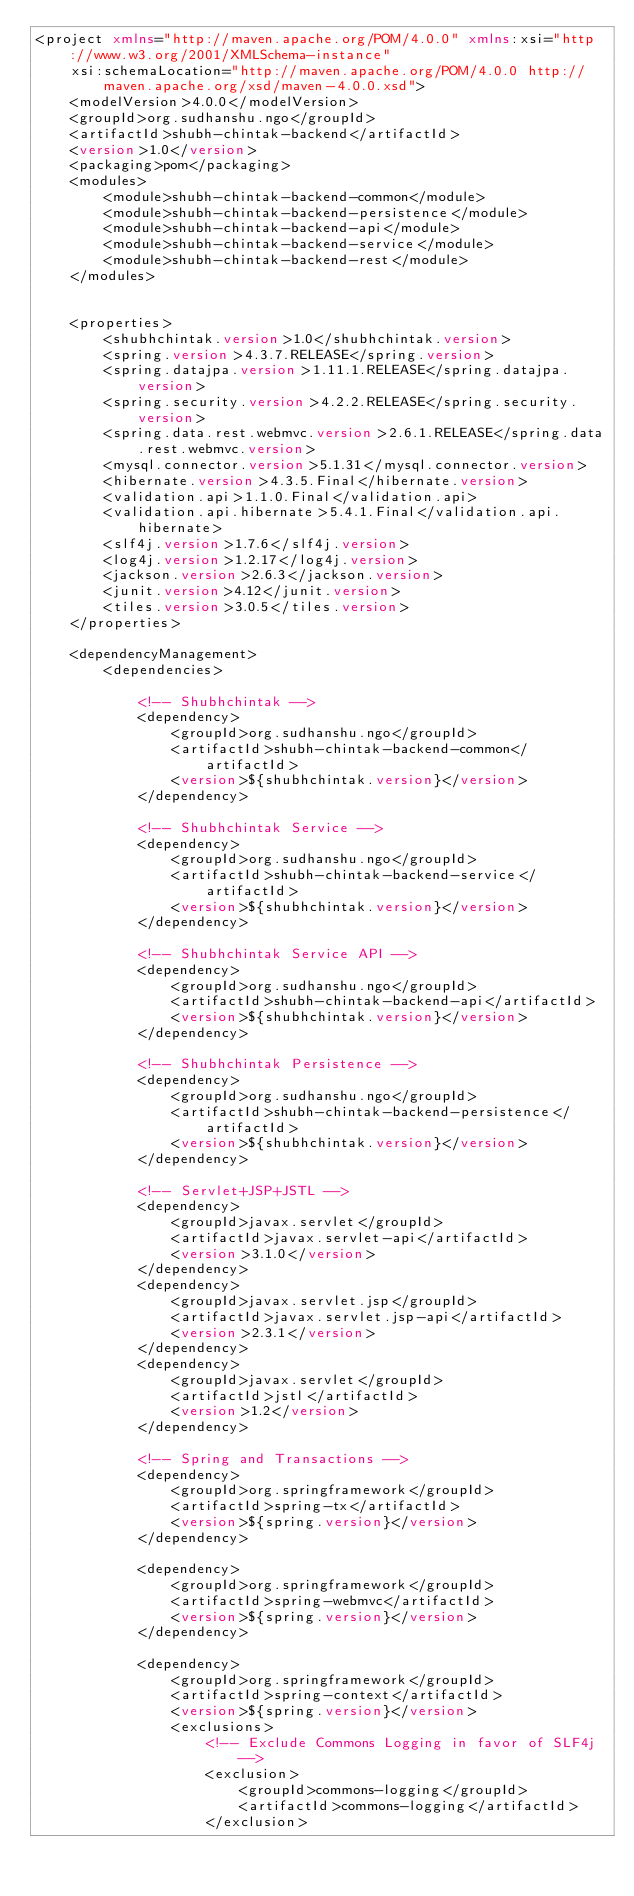<code> <loc_0><loc_0><loc_500><loc_500><_XML_><project xmlns="http://maven.apache.org/POM/4.0.0" xmlns:xsi="http://www.w3.org/2001/XMLSchema-instance"
	xsi:schemaLocation="http://maven.apache.org/POM/4.0.0 http://maven.apache.org/xsd/maven-4.0.0.xsd">
	<modelVersion>4.0.0</modelVersion>
	<groupId>org.sudhanshu.ngo</groupId>
	<artifactId>shubh-chintak-backend</artifactId>
	<version>1.0</version>
	<packaging>pom</packaging>
	<modules>
		<module>shubh-chintak-backend-common</module>
		<module>shubh-chintak-backend-persistence</module>
		<module>shubh-chintak-backend-api</module>
		<module>shubh-chintak-backend-service</module>
		<module>shubh-chintak-backend-rest</module>
	</modules>


	<properties>
		<shubhchintak.version>1.0</shubhchintak.version>
		<spring.version>4.3.7.RELEASE</spring.version>
		<spring.datajpa.version>1.11.1.RELEASE</spring.datajpa.version>
		<spring.security.version>4.2.2.RELEASE</spring.security.version>
		<spring.data.rest.webmvc.version>2.6.1.RELEASE</spring.data.rest.webmvc.version>
		<mysql.connector.version>5.1.31</mysql.connector.version>
		<hibernate.version>4.3.5.Final</hibernate.version>
		<validation.api>1.1.0.Final</validation.api>
		<validation.api.hibernate>5.4.1.Final</validation.api.hibernate>
		<slf4j.version>1.7.6</slf4j.version>
		<log4j.version>1.2.17</log4j.version>
		<jackson.version>2.6.3</jackson.version>
		<junit.version>4.12</junit.version>
		<tiles.version>3.0.5</tiles.version>
	</properties>

	<dependencyManagement>
		<dependencies>

			<!-- Shubhchintak -->
			<dependency>
				<groupId>org.sudhanshu.ngo</groupId>
				<artifactId>shubh-chintak-backend-common</artifactId>
				<version>${shubhchintak.version}</version>
			</dependency>

			<!-- Shubhchintak Service -->
			<dependency>
				<groupId>org.sudhanshu.ngo</groupId>
				<artifactId>shubh-chintak-backend-service</artifactId>
				<version>${shubhchintak.version}</version>
			</dependency>

			<!-- Shubhchintak Service API -->
			<dependency>
				<groupId>org.sudhanshu.ngo</groupId>
				<artifactId>shubh-chintak-backend-api</artifactId>
				<version>${shubhchintak.version}</version>
			</dependency>

			<!-- Shubhchintak Persistence -->
			<dependency>
				<groupId>org.sudhanshu.ngo</groupId>
				<artifactId>shubh-chintak-backend-persistence</artifactId>
				<version>${shubhchintak.version}</version>
			</dependency>

			<!-- Servlet+JSP+JSTL -->
			<dependency>
				<groupId>javax.servlet</groupId>
				<artifactId>javax.servlet-api</artifactId>
				<version>3.1.0</version>
			</dependency>
			<dependency>
				<groupId>javax.servlet.jsp</groupId>
				<artifactId>javax.servlet.jsp-api</artifactId>
				<version>2.3.1</version>
			</dependency>
			<dependency>
				<groupId>javax.servlet</groupId>
				<artifactId>jstl</artifactId>
				<version>1.2</version>
			</dependency>

			<!-- Spring and Transactions -->
			<dependency>
				<groupId>org.springframework</groupId>
				<artifactId>spring-tx</artifactId>
				<version>${spring.version}</version>
			</dependency>

			<dependency>
				<groupId>org.springframework</groupId>
				<artifactId>spring-webmvc</artifactId>
				<version>${spring.version}</version>
			</dependency>

			<dependency>
				<groupId>org.springframework</groupId>
				<artifactId>spring-context</artifactId>
				<version>${spring.version}</version>
				<exclusions>
					<!-- Exclude Commons Logging in favor of SLF4j -->
					<exclusion>
						<groupId>commons-logging</groupId>
						<artifactId>commons-logging</artifactId>
					</exclusion></code> 